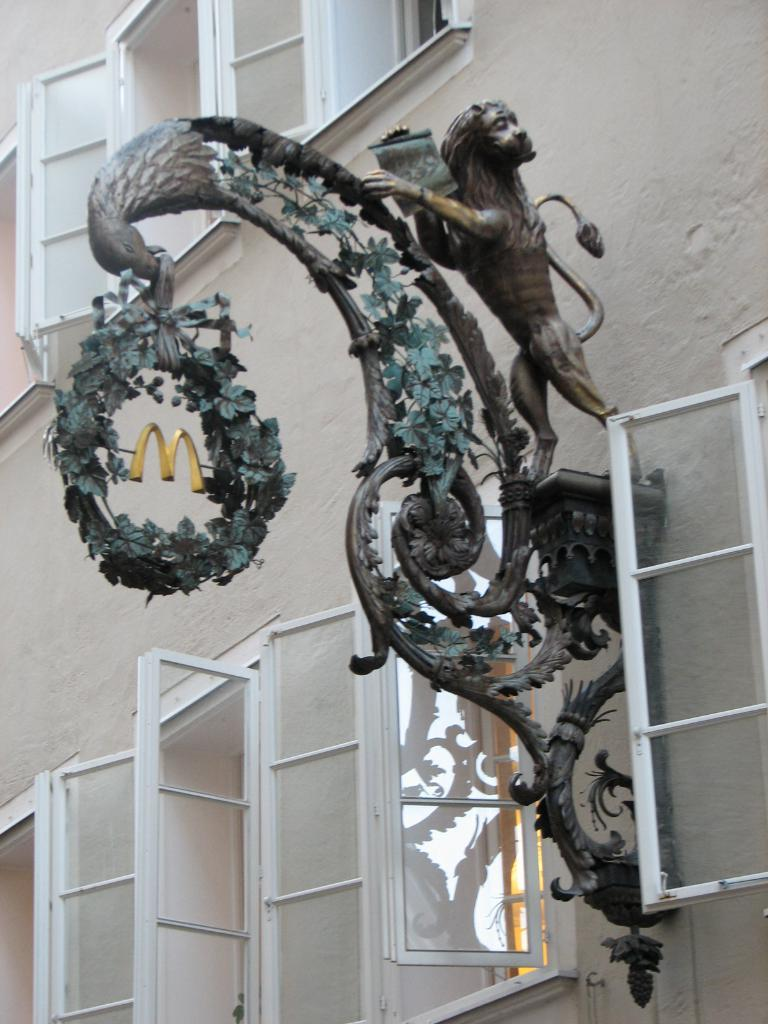What type of structure is visible in the image? There is a building in the image. What feature can be seen on the building? The building has windows. Is there any specific detail about the building that stands out? Yes, there is a Salzburg statue attached to the building. What type of card can be seen in the hands of the Salzburg statue? There is no card present in the image, as the Salzburg statue is a stationary object attached to the building. 